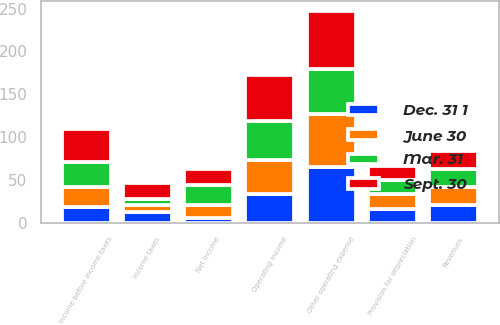Convert chart. <chart><loc_0><loc_0><loc_500><loc_500><stacked_bar_chart><ecel><fcel>Revenues<fcel>Other operating expense<fcel>Provision for depreciation<fcel>Operating Income<fcel>Income before income taxes<fcel>Income taxes<fcel>Net Income<nl><fcel>Sept. 30<fcel>21.05<fcel>67<fcel>15.8<fcel>54.3<fcel>38.8<fcel>19<fcel>19.8<nl><fcel>June 30<fcel>21.05<fcel>61.7<fcel>17.7<fcel>39.2<fcel>23.1<fcel>7.6<fcel>15.5<nl><fcel>Mar. 31<fcel>21.05<fcel>53.4<fcel>16<fcel>45.3<fcel>29.4<fcel>7.1<fcel>22.3<nl><fcel>Dec. 31 1<fcel>21.05<fcel>64.9<fcel>16.2<fcel>33.9<fcel>18.2<fcel>12.6<fcel>5.6<nl></chart> 